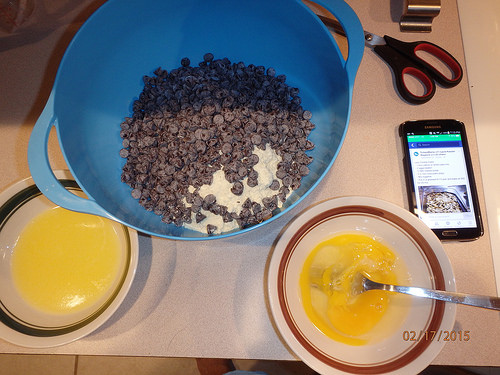<image>
Is there a cookie pan in the phone? Yes. The cookie pan is contained within or inside the phone, showing a containment relationship. 